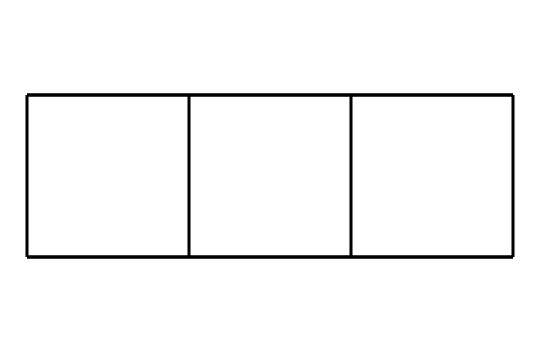What is the name of this chemical compound? The SMILES representation corresponds to a saturated hydrocarbon with a unique cubic structure known as cubane.
Answer: cubane How many carbon atoms are present in this structure? By analyzing the SMILES representation, we can identify that there are eight carbon atoms represented in the formula.
Answer: 8 What type of chemical structure does cubane represent? Cubane is classified as a cage compound due to its three-dimensional arrangement of atoms, forming a rigid and closed structure.
Answer: cage compound How many hydrogen atoms are bonded to each carbon in cubane? Each carbon atom in cubane is bonded to two hydrogen atoms, resulting in a total of 16 hydrogen atoms in the structure.
Answer: 16 What is the total number of bonds in the cubane molecule? The structure consists of eight carbon-carbon bonds and 16 carbon-hydrogen bonds, leading to a total of 24 covalent bonds within the molecule.
Answer: 24 What is the primary use of cubane in film pyrotechnics? Cubane's highly energetic properties make it suitable as a potential high-energy explosive or propellant in film pyrotechnics.
Answer: explosive 